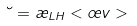Convert formula to latex. <formula><loc_0><loc_0><loc_500><loc_500>\lambda = \rho _ { L H } < \sigma v ></formula> 